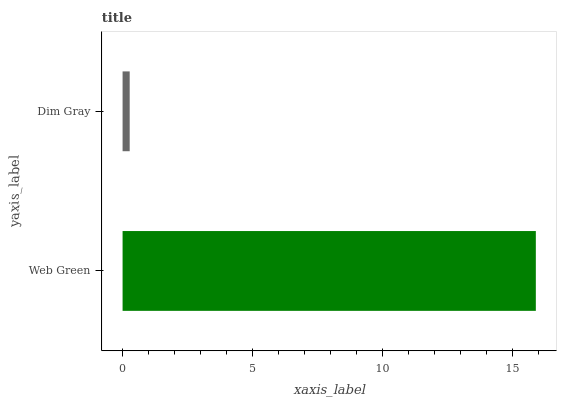Is Dim Gray the minimum?
Answer yes or no. Yes. Is Web Green the maximum?
Answer yes or no. Yes. Is Dim Gray the maximum?
Answer yes or no. No. Is Web Green greater than Dim Gray?
Answer yes or no. Yes. Is Dim Gray less than Web Green?
Answer yes or no. Yes. Is Dim Gray greater than Web Green?
Answer yes or no. No. Is Web Green less than Dim Gray?
Answer yes or no. No. Is Web Green the high median?
Answer yes or no. Yes. Is Dim Gray the low median?
Answer yes or no. Yes. Is Dim Gray the high median?
Answer yes or no. No. Is Web Green the low median?
Answer yes or no. No. 